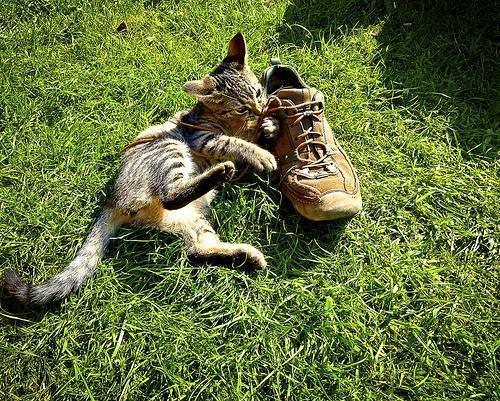How many kittens are there?
Give a very brief answer. 1. 